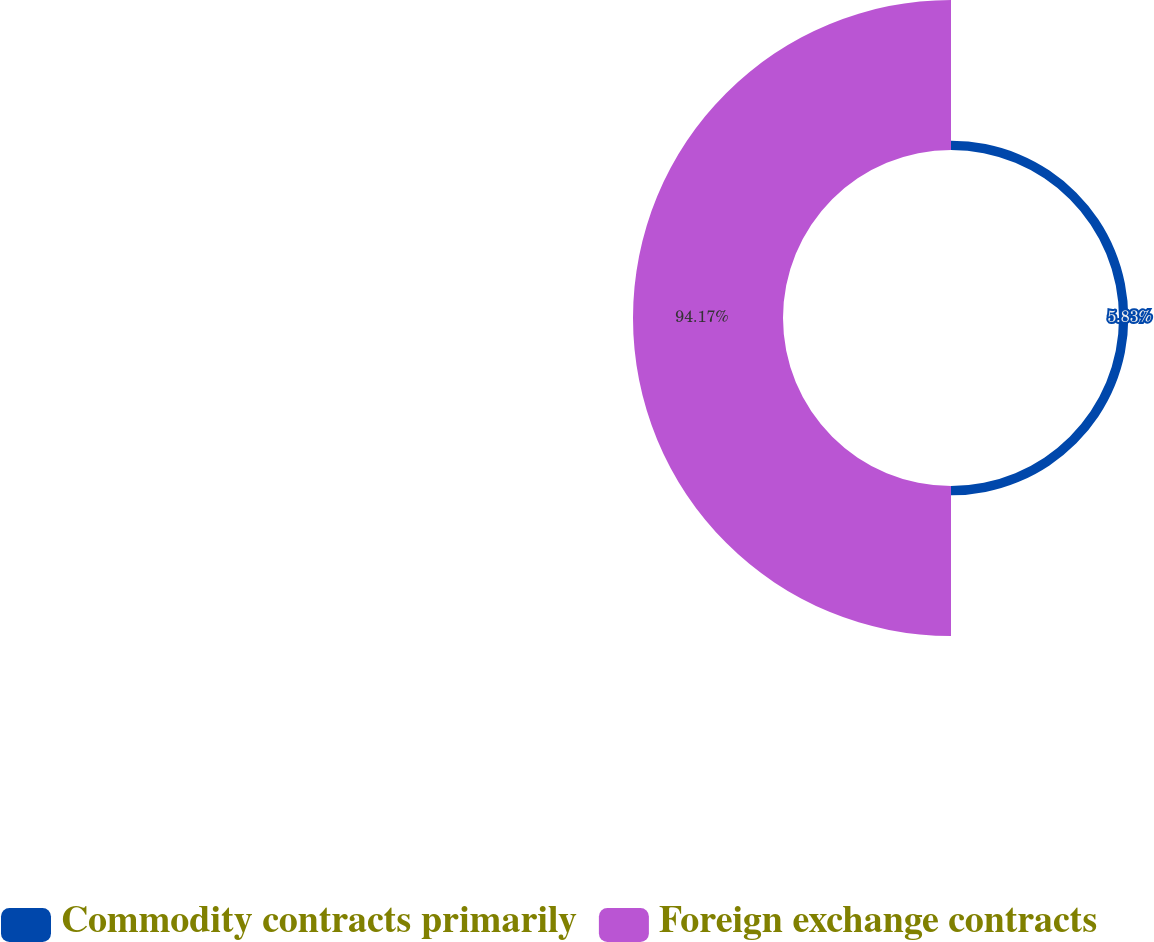<chart> <loc_0><loc_0><loc_500><loc_500><pie_chart><fcel>Commodity contracts primarily<fcel>Foreign exchange contracts<nl><fcel>5.83%<fcel>94.17%<nl></chart> 